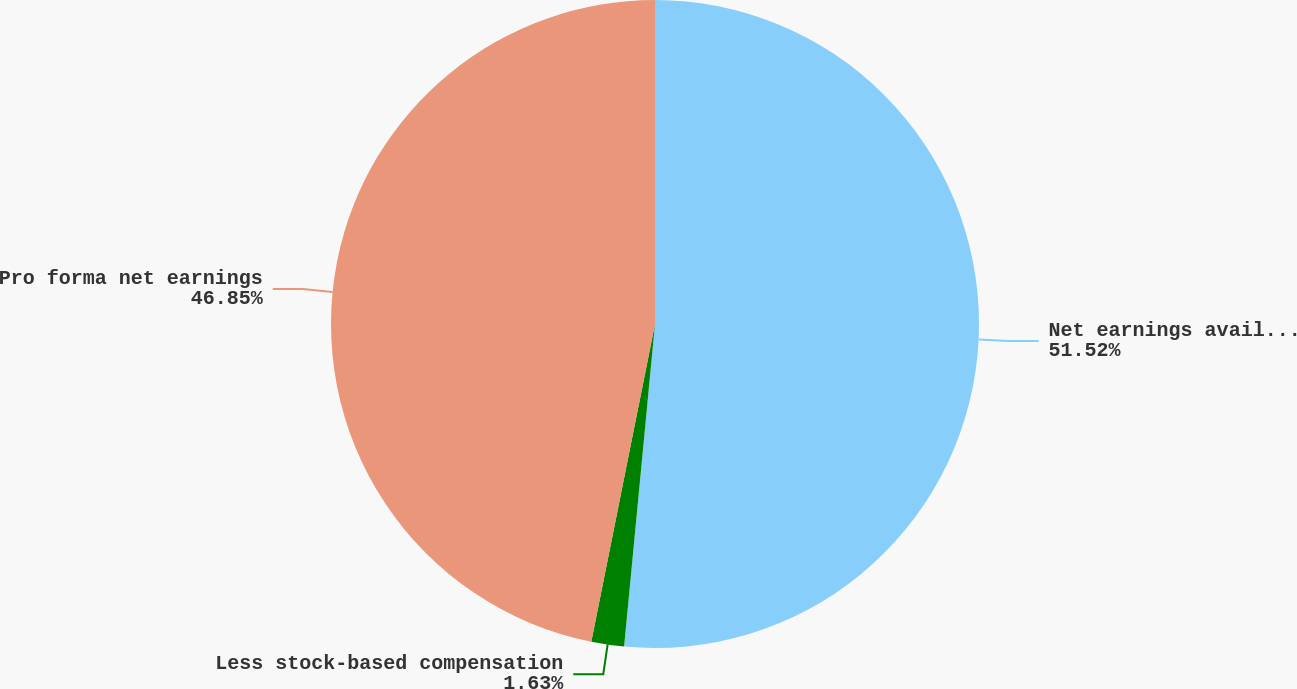<chart> <loc_0><loc_0><loc_500><loc_500><pie_chart><fcel>Net earnings available to<fcel>Less stock-based compensation<fcel>Pro forma net earnings<nl><fcel>51.52%<fcel>1.63%<fcel>46.85%<nl></chart> 